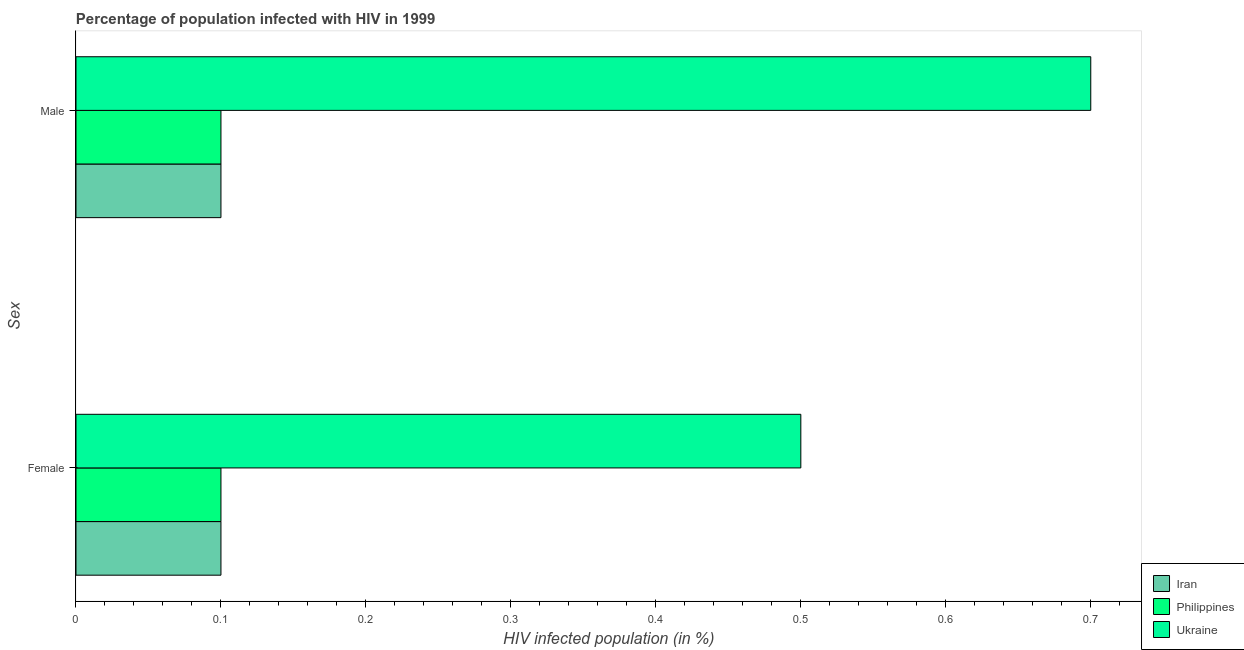How many groups of bars are there?
Your answer should be compact. 2. Are the number of bars on each tick of the Y-axis equal?
Provide a succinct answer. Yes. How many bars are there on the 2nd tick from the top?
Your answer should be compact. 3. How many bars are there on the 1st tick from the bottom?
Make the answer very short. 3. What is the label of the 2nd group of bars from the top?
Make the answer very short. Female. Across all countries, what is the maximum percentage of males who are infected with hiv?
Offer a very short reply. 0.7. In which country was the percentage of females who are infected with hiv maximum?
Make the answer very short. Ukraine. In which country was the percentage of males who are infected with hiv minimum?
Your response must be concise. Iran. What is the difference between the percentage of males who are infected with hiv in Philippines and the percentage of females who are infected with hiv in Iran?
Provide a short and direct response. 0. What is the average percentage of females who are infected with hiv per country?
Provide a short and direct response. 0.23. What is the difference between the percentage of females who are infected with hiv and percentage of males who are infected with hiv in Ukraine?
Keep it short and to the point. -0.2. What is the ratio of the percentage of males who are infected with hiv in Iran to that in Philippines?
Ensure brevity in your answer.  1. Is the percentage of females who are infected with hiv in Iran less than that in Ukraine?
Make the answer very short. Yes. What does the 3rd bar from the top in Male represents?
Give a very brief answer. Iran. How many bars are there?
Make the answer very short. 6. Are all the bars in the graph horizontal?
Your answer should be very brief. Yes. How many countries are there in the graph?
Your answer should be very brief. 3. Does the graph contain any zero values?
Keep it short and to the point. No. What is the title of the graph?
Offer a very short reply. Percentage of population infected with HIV in 1999. Does "Angola" appear as one of the legend labels in the graph?
Offer a very short reply. No. What is the label or title of the X-axis?
Make the answer very short. HIV infected population (in %). What is the label or title of the Y-axis?
Give a very brief answer. Sex. What is the HIV infected population (in %) of Iran in Female?
Offer a terse response. 0.1. What is the HIV infected population (in %) of Philippines in Female?
Your answer should be compact. 0.1. What is the HIV infected population (in %) in Ukraine in Female?
Give a very brief answer. 0.5. What is the HIV infected population (in %) of Philippines in Male?
Make the answer very short. 0.1. Across all Sex, what is the minimum HIV infected population (in %) of Philippines?
Your response must be concise. 0.1. What is the total HIV infected population (in %) in Iran in the graph?
Provide a succinct answer. 0.2. What is the total HIV infected population (in %) of Philippines in the graph?
Give a very brief answer. 0.2. What is the difference between the HIV infected population (in %) in Iran in Female and that in Male?
Offer a very short reply. 0. What is the difference between the HIV infected population (in %) of Philippines in Female and that in Male?
Give a very brief answer. 0. What is the average HIV infected population (in %) in Philippines per Sex?
Provide a short and direct response. 0.1. What is the difference between the HIV infected population (in %) in Iran and HIV infected population (in %) in Philippines in Female?
Offer a terse response. 0. What is the difference between the HIV infected population (in %) in Iran and HIV infected population (in %) in Ukraine in Female?
Keep it short and to the point. -0.4. What is the difference between the HIV infected population (in %) of Iran and HIV infected population (in %) of Ukraine in Male?
Your answer should be very brief. -0.6. What is the difference between the HIV infected population (in %) of Philippines and HIV infected population (in %) of Ukraine in Male?
Provide a short and direct response. -0.6. What is the ratio of the HIV infected population (in %) in Iran in Female to that in Male?
Make the answer very short. 1. What is the ratio of the HIV infected population (in %) in Philippines in Female to that in Male?
Provide a short and direct response. 1. What is the difference between the highest and the second highest HIV infected population (in %) in Philippines?
Make the answer very short. 0. What is the difference between the highest and the lowest HIV infected population (in %) in Philippines?
Your answer should be compact. 0. 